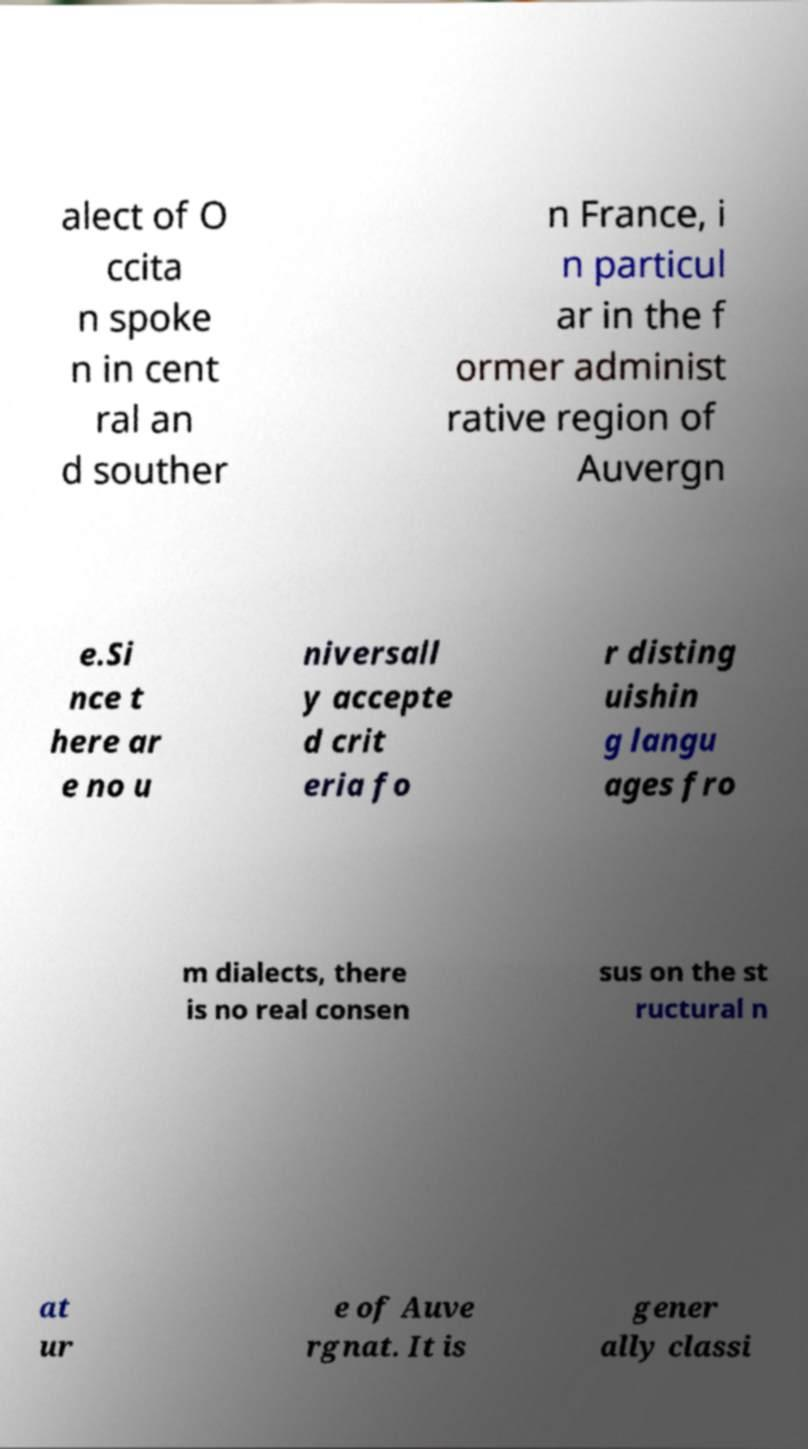Could you extract and type out the text from this image? alect of O ccita n spoke n in cent ral an d souther n France, i n particul ar in the f ormer administ rative region of Auvergn e.Si nce t here ar e no u niversall y accepte d crit eria fo r disting uishin g langu ages fro m dialects, there is no real consen sus on the st ructural n at ur e of Auve rgnat. It is gener ally classi 